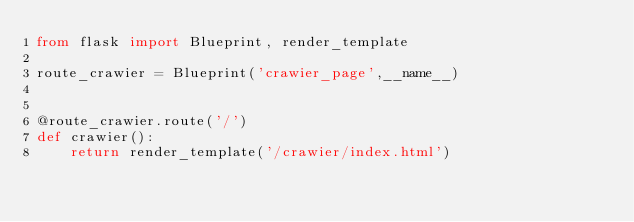<code> <loc_0><loc_0><loc_500><loc_500><_Python_>from flask import Blueprint, render_template

route_crawier = Blueprint('crawier_page',__name__)


@route_crawier.route('/')
def crawier():
    return render_template('/crawier/index.html')</code> 